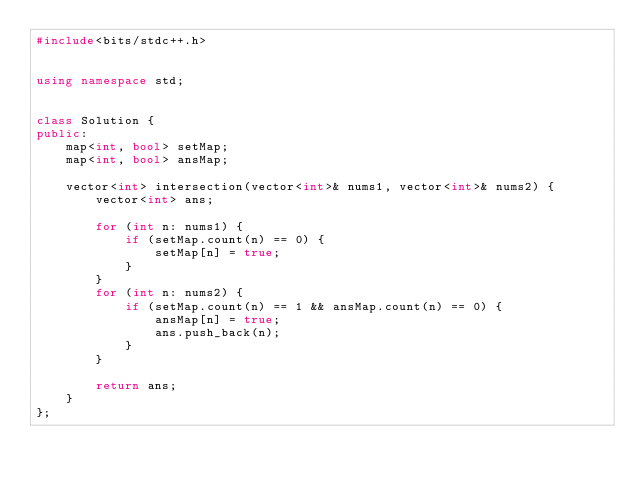Convert code to text. <code><loc_0><loc_0><loc_500><loc_500><_C++_>#include<bits/stdc++.h>


using namespace std;


class Solution {
public:
    map<int, bool> setMap;
    map<int, bool> ansMap;

    vector<int> intersection(vector<int>& nums1, vector<int>& nums2) {
        vector<int> ans;

        for (int n: nums1) {
            if (setMap.count(n) == 0) {
                setMap[n] = true;
            }
        }
        for (int n: nums2) {
            if (setMap.count(n) == 1 && ansMap.count(n) == 0) {
                ansMap[n] = true;
                ans.push_back(n);
            }
        }

        return ans;
    }
};</code> 